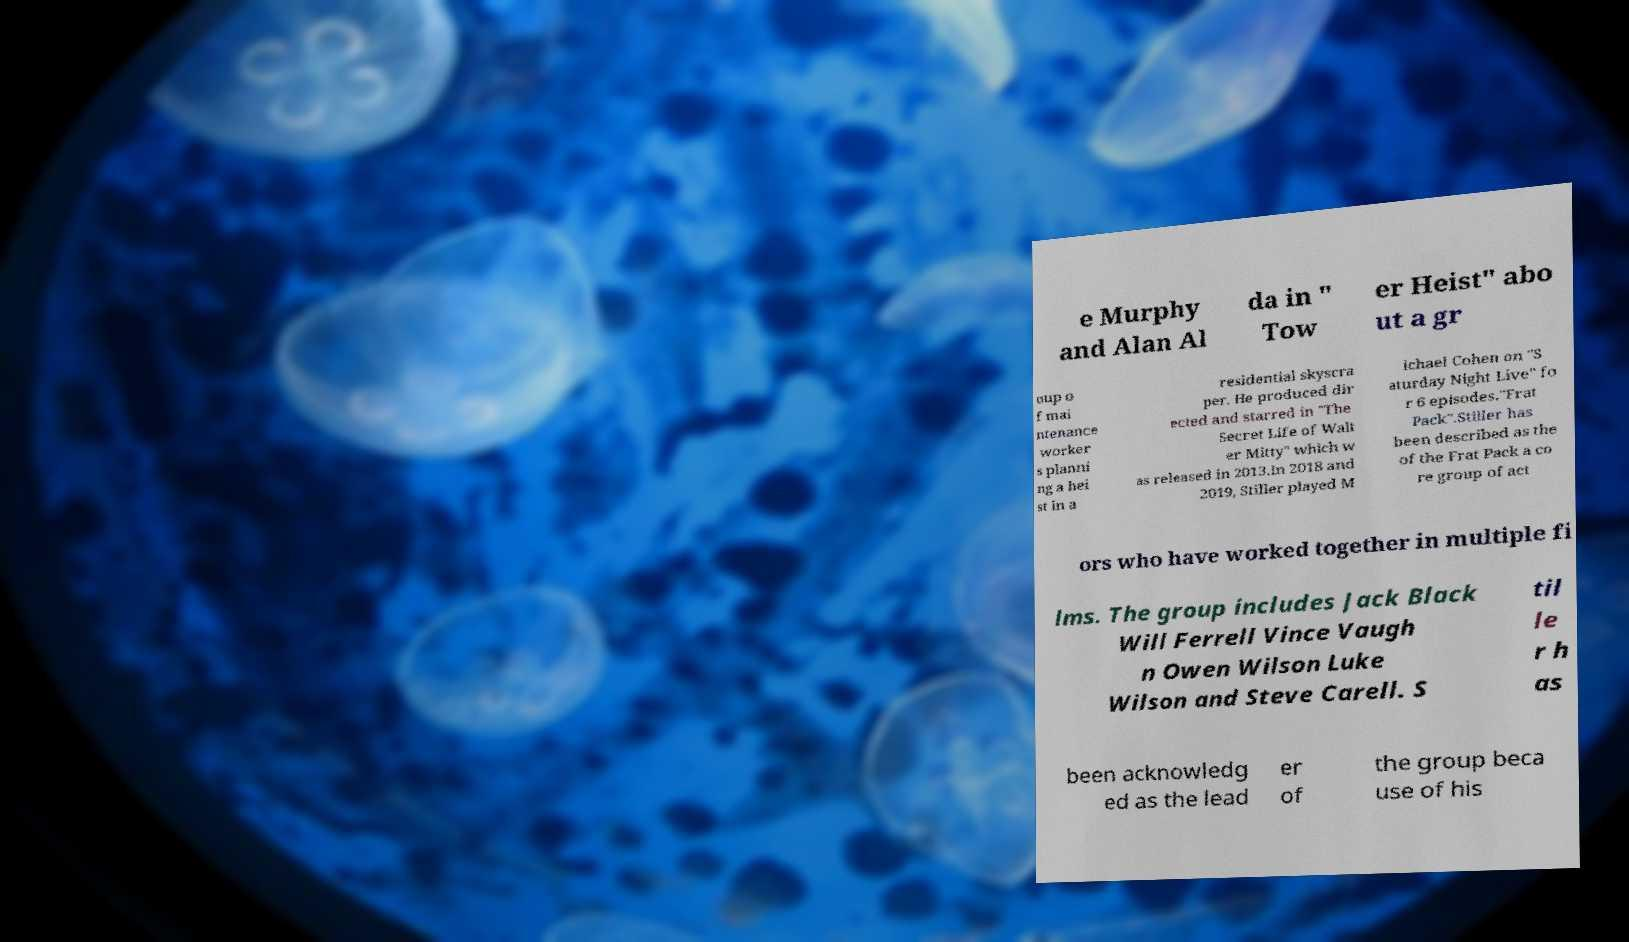Can you accurately transcribe the text from the provided image for me? e Murphy and Alan Al da in " Tow er Heist" abo ut a gr oup o f mai ntenance worker s planni ng a hei st in a residential skyscra per. He produced dir ected and starred in "The Secret Life of Walt er Mitty" which w as released in 2013.In 2018 and 2019, Stiller played M ichael Cohen on "S aturday Night Live" fo r 6 episodes."Frat Pack".Stiller has been described as the of the Frat Pack a co re group of act ors who have worked together in multiple fi lms. The group includes Jack Black Will Ferrell Vince Vaugh n Owen Wilson Luke Wilson and Steve Carell. S til le r h as been acknowledg ed as the lead er of the group beca use of his 